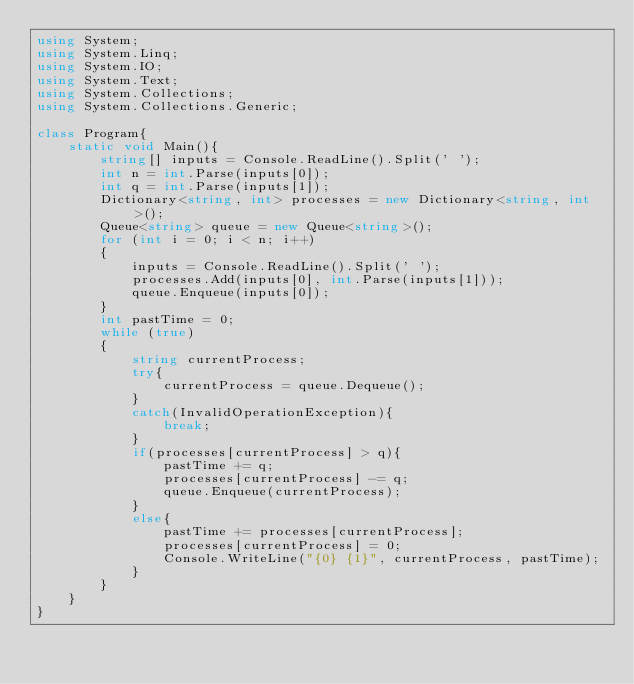<code> <loc_0><loc_0><loc_500><loc_500><_C#_>using System;
using System.Linq;
using System.IO;
using System.Text;
using System.Collections;
using System.Collections.Generic;
 
class Program{
    static void Main(){
        string[] inputs = Console.ReadLine().Split(' ');
        int n = int.Parse(inputs[0]);
        int q = int.Parse(inputs[1]);
        Dictionary<string, int> processes = new Dictionary<string, int>();
        Queue<string> queue = new Queue<string>();
        for (int i = 0; i < n; i++)
        {
            inputs = Console.ReadLine().Split(' ');
            processes.Add(inputs[0], int.Parse(inputs[1]));
            queue.Enqueue(inputs[0]);
        }
        int pastTime = 0;
        while (true)
        {
            string currentProcess;
            try{
                currentProcess = queue.Dequeue();
            }
            catch(InvalidOperationException){
                break;
            }
            if(processes[currentProcess] > q){
                pastTime += q;
                processes[currentProcess] -= q;
                queue.Enqueue(currentProcess);
            }
            else{
                pastTime += processes[currentProcess];
                processes[currentProcess] = 0;
                Console.WriteLine("{0} {1}", currentProcess, pastTime);
            }
        }
    }
}</code> 